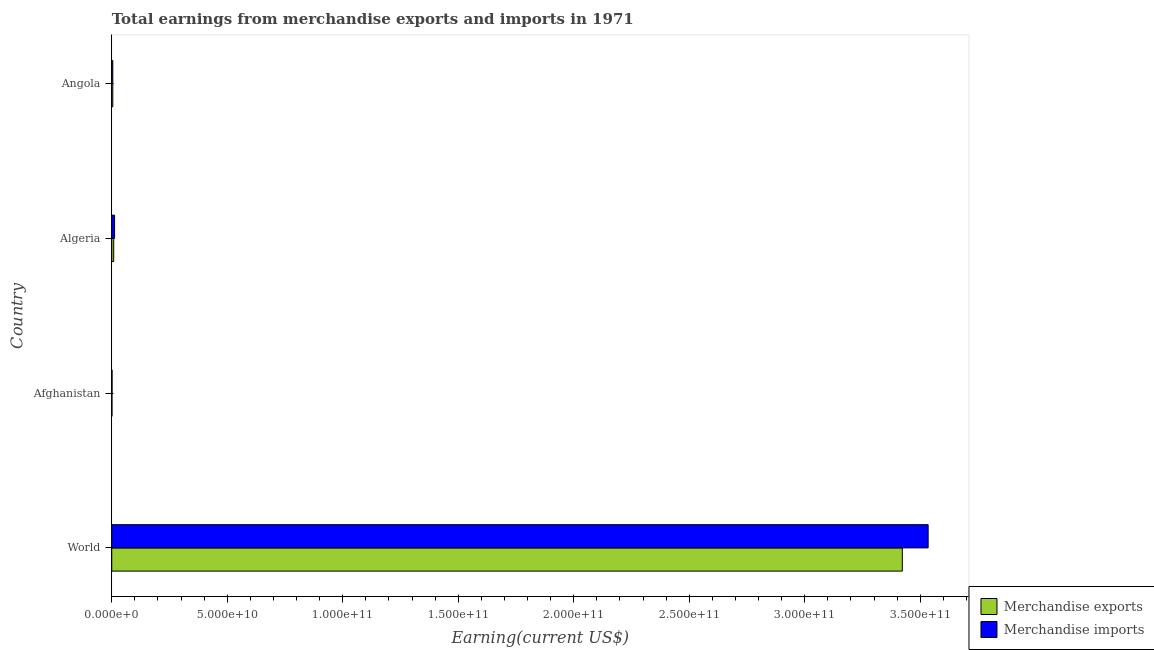How many groups of bars are there?
Your answer should be compact. 4. Are the number of bars per tick equal to the number of legend labels?
Your answer should be compact. Yes. Are the number of bars on each tick of the Y-axis equal?
Ensure brevity in your answer.  Yes. How many bars are there on the 2nd tick from the top?
Keep it short and to the point. 2. How many bars are there on the 2nd tick from the bottom?
Your answer should be compact. 2. What is the label of the 1st group of bars from the top?
Your response must be concise. Angola. In how many cases, is the number of bars for a given country not equal to the number of legend labels?
Your answer should be compact. 0. What is the earnings from merchandise imports in Algeria?
Give a very brief answer. 1.23e+09. Across all countries, what is the maximum earnings from merchandise imports?
Provide a succinct answer. 3.53e+11. Across all countries, what is the minimum earnings from merchandise exports?
Offer a very short reply. 1.00e+08. In which country was the earnings from merchandise imports maximum?
Offer a very short reply. World. In which country was the earnings from merchandise exports minimum?
Your answer should be compact. Afghanistan. What is the total earnings from merchandise exports in the graph?
Keep it short and to the point. 3.44e+11. What is the difference between the earnings from merchandise exports in Angola and that in World?
Your answer should be very brief. -3.42e+11. What is the difference between the earnings from merchandise imports in World and the earnings from merchandise exports in Afghanistan?
Keep it short and to the point. 3.53e+11. What is the average earnings from merchandise exports per country?
Your answer should be compact. 8.59e+1. What is the difference between the earnings from merchandise imports and earnings from merchandise exports in Afghanistan?
Your response must be concise. 4.10e+07. In how many countries, is the earnings from merchandise imports greater than 360000000000 US$?
Ensure brevity in your answer.  0. What is the ratio of the earnings from merchandise exports in Algeria to that in World?
Give a very brief answer. 0. Is the difference between the earnings from merchandise exports in Afghanistan and World greater than the difference between the earnings from merchandise imports in Afghanistan and World?
Provide a short and direct response. Yes. What is the difference between the highest and the second highest earnings from merchandise exports?
Your answer should be very brief. 3.41e+11. What is the difference between the highest and the lowest earnings from merchandise imports?
Keep it short and to the point. 3.53e+11. In how many countries, is the earnings from merchandise imports greater than the average earnings from merchandise imports taken over all countries?
Give a very brief answer. 1. Is the sum of the earnings from merchandise exports in Angola and World greater than the maximum earnings from merchandise imports across all countries?
Make the answer very short. No. What does the 1st bar from the bottom in Afghanistan represents?
Offer a very short reply. Merchandise exports. What is the difference between two consecutive major ticks on the X-axis?
Ensure brevity in your answer.  5.00e+1. Are the values on the major ticks of X-axis written in scientific E-notation?
Keep it short and to the point. Yes. Does the graph contain any zero values?
Ensure brevity in your answer.  No. How are the legend labels stacked?
Ensure brevity in your answer.  Vertical. What is the title of the graph?
Offer a terse response. Total earnings from merchandise exports and imports in 1971. What is the label or title of the X-axis?
Make the answer very short. Earning(current US$). What is the Earning(current US$) of Merchandise exports in World?
Your answer should be very brief. 3.42e+11. What is the Earning(current US$) of Merchandise imports in World?
Give a very brief answer. 3.53e+11. What is the Earning(current US$) of Merchandise imports in Afghanistan?
Your answer should be very brief. 1.41e+08. What is the Earning(current US$) of Merchandise exports in Algeria?
Your response must be concise. 8.57e+08. What is the Earning(current US$) of Merchandise imports in Algeria?
Offer a very short reply. 1.23e+09. What is the Earning(current US$) in Merchandise exports in Angola?
Ensure brevity in your answer.  4.55e+08. What is the Earning(current US$) of Merchandise imports in Angola?
Offer a terse response. 4.45e+08. Across all countries, what is the maximum Earning(current US$) in Merchandise exports?
Provide a succinct answer. 3.42e+11. Across all countries, what is the maximum Earning(current US$) in Merchandise imports?
Make the answer very short. 3.53e+11. Across all countries, what is the minimum Earning(current US$) of Merchandise exports?
Your answer should be very brief. 1.00e+08. Across all countries, what is the minimum Earning(current US$) of Merchandise imports?
Ensure brevity in your answer.  1.41e+08. What is the total Earning(current US$) of Merchandise exports in the graph?
Your answer should be compact. 3.44e+11. What is the total Earning(current US$) of Merchandise imports in the graph?
Provide a succinct answer. 3.55e+11. What is the difference between the Earning(current US$) of Merchandise exports in World and that in Afghanistan?
Your response must be concise. 3.42e+11. What is the difference between the Earning(current US$) of Merchandise imports in World and that in Afghanistan?
Offer a terse response. 3.53e+11. What is the difference between the Earning(current US$) of Merchandise exports in World and that in Algeria?
Ensure brevity in your answer.  3.41e+11. What is the difference between the Earning(current US$) in Merchandise imports in World and that in Algeria?
Offer a very short reply. 3.52e+11. What is the difference between the Earning(current US$) in Merchandise exports in World and that in Angola?
Give a very brief answer. 3.42e+11. What is the difference between the Earning(current US$) of Merchandise imports in World and that in Angola?
Offer a terse response. 3.53e+11. What is the difference between the Earning(current US$) of Merchandise exports in Afghanistan and that in Algeria?
Provide a short and direct response. -7.57e+08. What is the difference between the Earning(current US$) of Merchandise imports in Afghanistan and that in Algeria?
Give a very brief answer. -1.09e+09. What is the difference between the Earning(current US$) of Merchandise exports in Afghanistan and that in Angola?
Give a very brief answer. -3.55e+08. What is the difference between the Earning(current US$) in Merchandise imports in Afghanistan and that in Angola?
Provide a succinct answer. -3.04e+08. What is the difference between the Earning(current US$) of Merchandise exports in Algeria and that in Angola?
Give a very brief answer. 4.02e+08. What is the difference between the Earning(current US$) in Merchandise imports in Algeria and that in Angola?
Make the answer very short. 7.82e+08. What is the difference between the Earning(current US$) of Merchandise exports in World and the Earning(current US$) of Merchandise imports in Afghanistan?
Provide a succinct answer. 3.42e+11. What is the difference between the Earning(current US$) of Merchandise exports in World and the Earning(current US$) of Merchandise imports in Algeria?
Give a very brief answer. 3.41e+11. What is the difference between the Earning(current US$) in Merchandise exports in World and the Earning(current US$) in Merchandise imports in Angola?
Make the answer very short. 3.42e+11. What is the difference between the Earning(current US$) in Merchandise exports in Afghanistan and the Earning(current US$) in Merchandise imports in Algeria?
Your response must be concise. -1.13e+09. What is the difference between the Earning(current US$) in Merchandise exports in Afghanistan and the Earning(current US$) in Merchandise imports in Angola?
Your answer should be very brief. -3.45e+08. What is the difference between the Earning(current US$) of Merchandise exports in Algeria and the Earning(current US$) of Merchandise imports in Angola?
Your answer should be very brief. 4.12e+08. What is the average Earning(current US$) in Merchandise exports per country?
Offer a very short reply. 8.59e+1. What is the average Earning(current US$) in Merchandise imports per country?
Your answer should be compact. 8.88e+1. What is the difference between the Earning(current US$) in Merchandise exports and Earning(current US$) in Merchandise imports in World?
Offer a terse response. -1.12e+1. What is the difference between the Earning(current US$) in Merchandise exports and Earning(current US$) in Merchandise imports in Afghanistan?
Give a very brief answer. -4.10e+07. What is the difference between the Earning(current US$) of Merchandise exports and Earning(current US$) of Merchandise imports in Algeria?
Your answer should be compact. -3.70e+08. What is the difference between the Earning(current US$) of Merchandise exports and Earning(current US$) of Merchandise imports in Angola?
Offer a terse response. 1.00e+07. What is the ratio of the Earning(current US$) of Merchandise exports in World to that in Afghanistan?
Keep it short and to the point. 3422.56. What is the ratio of the Earning(current US$) in Merchandise imports in World to that in Afghanistan?
Provide a short and direct response. 2506.59. What is the ratio of the Earning(current US$) in Merchandise exports in World to that in Algeria?
Provide a short and direct response. 399.57. What is the ratio of the Earning(current US$) of Merchandise imports in World to that in Algeria?
Make the answer very short. 288.03. What is the ratio of the Earning(current US$) of Merchandise exports in World to that in Angola?
Your response must be concise. 752.21. What is the ratio of the Earning(current US$) of Merchandise imports in World to that in Angola?
Make the answer very short. 794.22. What is the ratio of the Earning(current US$) of Merchandise exports in Afghanistan to that in Algeria?
Make the answer very short. 0.12. What is the ratio of the Earning(current US$) in Merchandise imports in Afghanistan to that in Algeria?
Your answer should be very brief. 0.11. What is the ratio of the Earning(current US$) of Merchandise exports in Afghanistan to that in Angola?
Keep it short and to the point. 0.22. What is the ratio of the Earning(current US$) in Merchandise imports in Afghanistan to that in Angola?
Provide a short and direct response. 0.32. What is the ratio of the Earning(current US$) in Merchandise exports in Algeria to that in Angola?
Offer a terse response. 1.88. What is the ratio of the Earning(current US$) of Merchandise imports in Algeria to that in Angola?
Offer a terse response. 2.76. What is the difference between the highest and the second highest Earning(current US$) in Merchandise exports?
Give a very brief answer. 3.41e+11. What is the difference between the highest and the second highest Earning(current US$) of Merchandise imports?
Provide a succinct answer. 3.52e+11. What is the difference between the highest and the lowest Earning(current US$) of Merchandise exports?
Offer a terse response. 3.42e+11. What is the difference between the highest and the lowest Earning(current US$) of Merchandise imports?
Keep it short and to the point. 3.53e+11. 